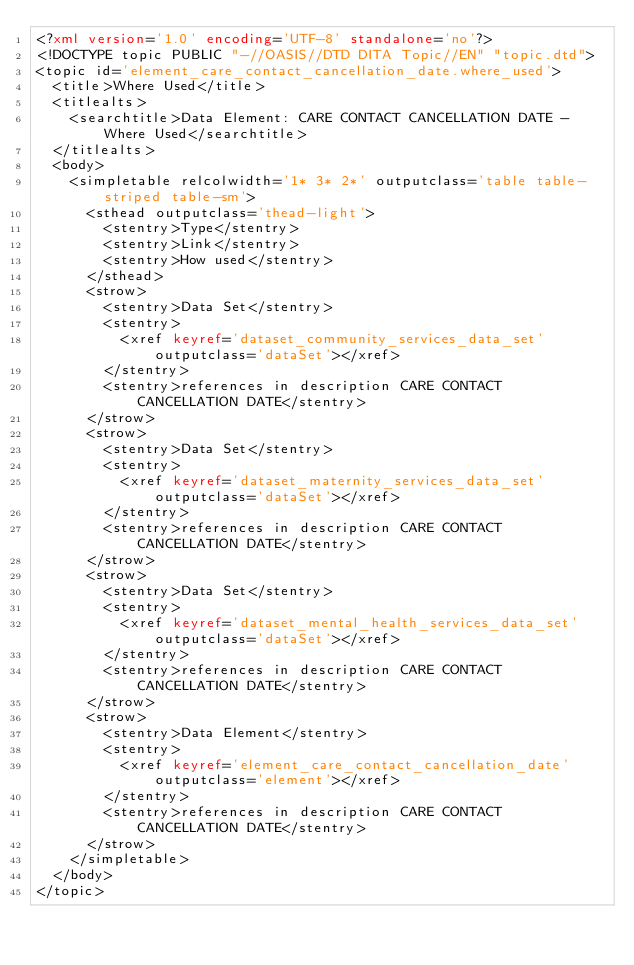Convert code to text. <code><loc_0><loc_0><loc_500><loc_500><_XML_><?xml version='1.0' encoding='UTF-8' standalone='no'?>
<!DOCTYPE topic PUBLIC "-//OASIS//DTD DITA Topic//EN" "topic.dtd">
<topic id='element_care_contact_cancellation_date.where_used'>
  <title>Where Used</title>
  <titlealts>
    <searchtitle>Data Element: CARE CONTACT CANCELLATION DATE - Where Used</searchtitle>
  </titlealts>
  <body>
    <simpletable relcolwidth='1* 3* 2*' outputclass='table table-striped table-sm'>
      <sthead outputclass='thead-light'>
        <stentry>Type</stentry>
        <stentry>Link</stentry>
        <stentry>How used</stentry>
      </sthead>
      <strow>
        <stentry>Data Set</stentry>
        <stentry>
          <xref keyref='dataset_community_services_data_set' outputclass='dataSet'></xref>
        </stentry>
        <stentry>references in description CARE CONTACT CANCELLATION DATE</stentry>
      </strow>
      <strow>
        <stentry>Data Set</stentry>
        <stentry>
          <xref keyref='dataset_maternity_services_data_set' outputclass='dataSet'></xref>
        </stentry>
        <stentry>references in description CARE CONTACT CANCELLATION DATE</stentry>
      </strow>
      <strow>
        <stentry>Data Set</stentry>
        <stentry>
          <xref keyref='dataset_mental_health_services_data_set' outputclass='dataSet'></xref>
        </stentry>
        <stentry>references in description CARE CONTACT CANCELLATION DATE</stentry>
      </strow>
      <strow>
        <stentry>Data Element</stentry>
        <stentry>
          <xref keyref='element_care_contact_cancellation_date' outputclass='element'></xref>
        </stentry>
        <stentry>references in description CARE CONTACT CANCELLATION DATE</stentry>
      </strow>
    </simpletable>
  </body>
</topic></code> 